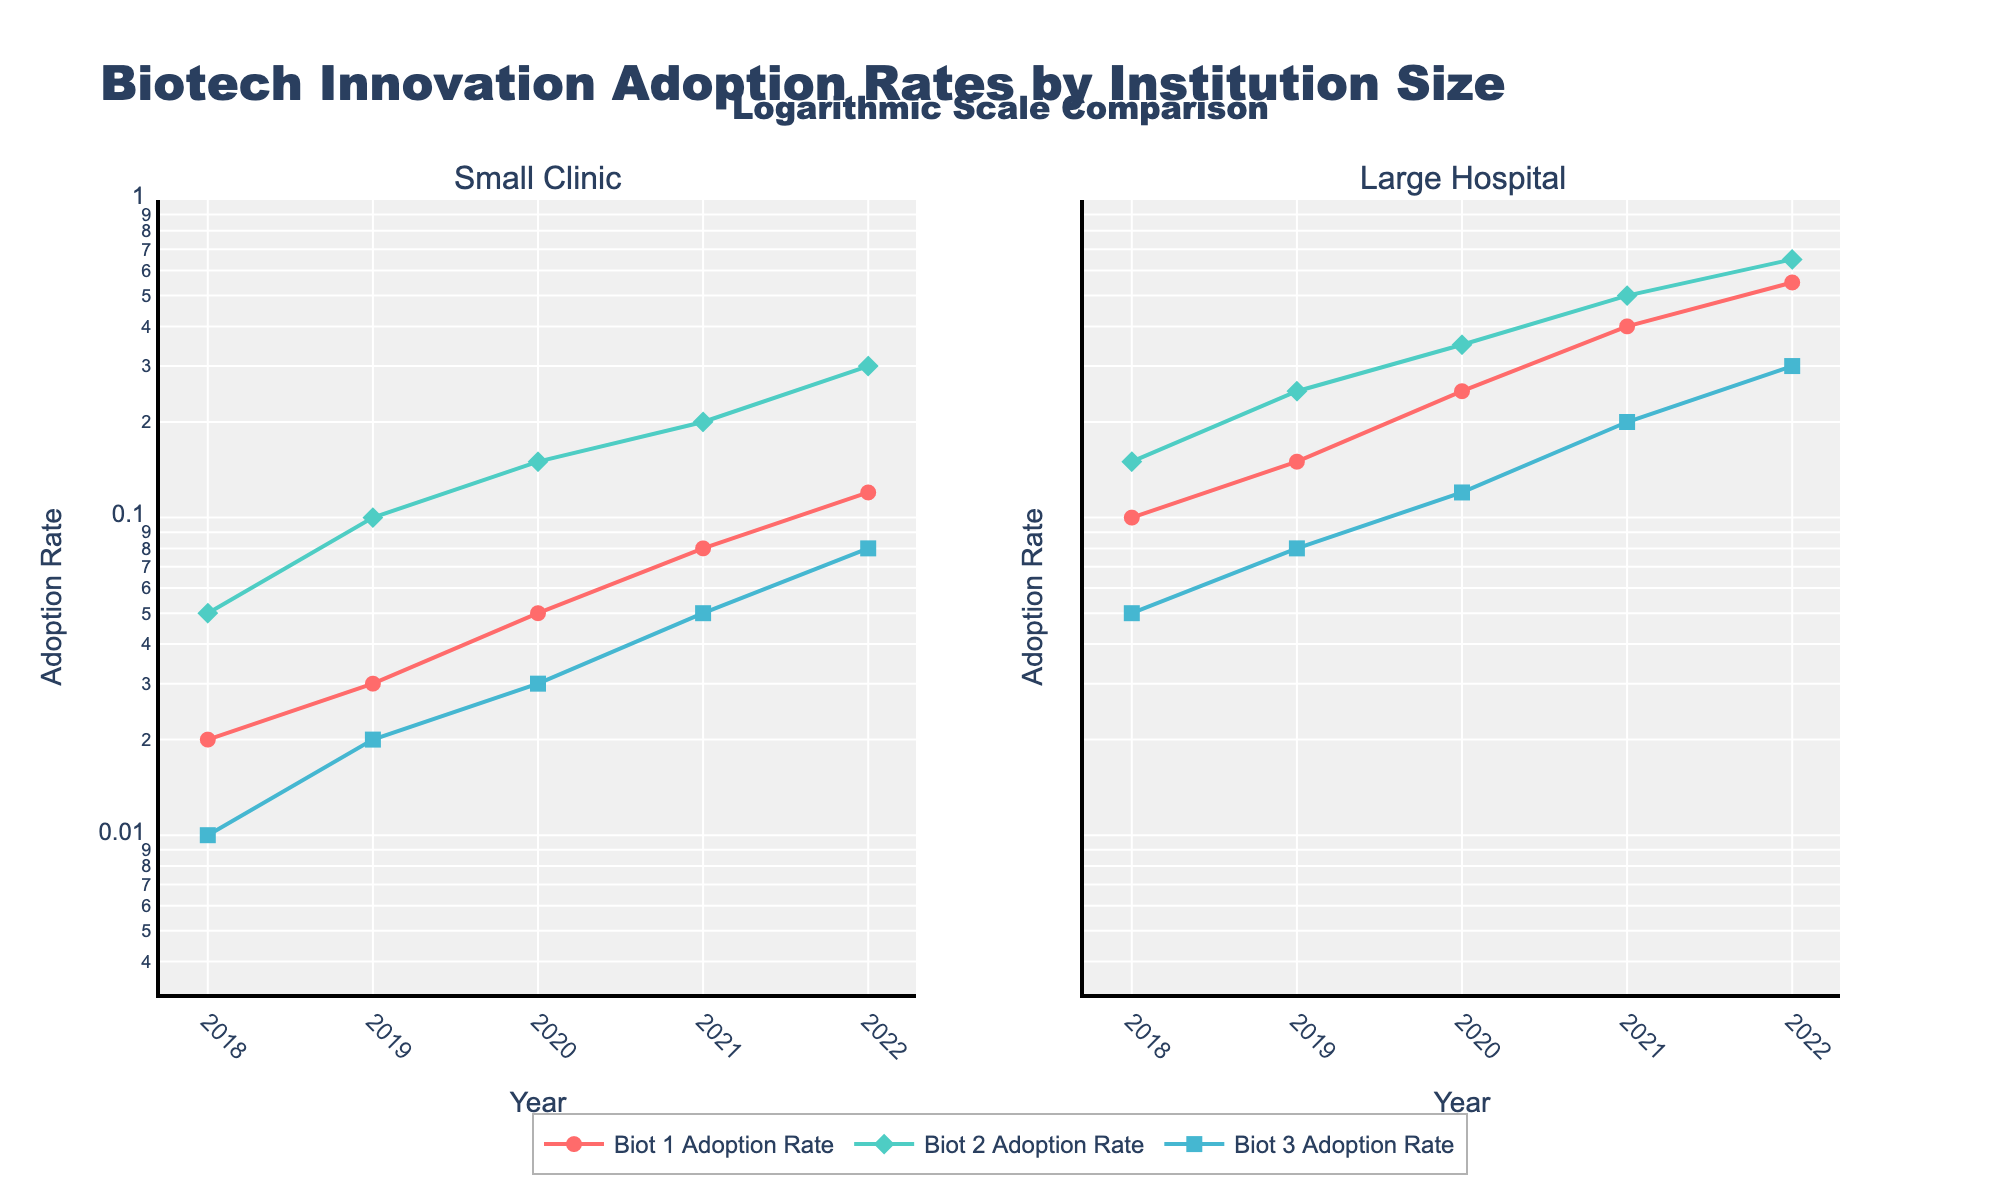What is the title of the figure? The title of the figure is clearly displayed at the top and reads "Biotech Innovation Adoption Rates by Institution Size".
Answer: Biotech Innovation Adoption Rates by Institution Size Which institution size has higher adoption rates overall in 2022 for all biotechs? By comparing the adoption rates for Biot 1, Biot 2, and Biot 3 in 2022, the large hospital data points (0.55, 0.65, 0.30) are higher than the small clinic data points (0.12, 0.30, 0.08) across all biotechs.
Answer: Large Hospital How does the adoption rate of Biot 1 in 2020 differ between small clinics and large hospitals? In 2020, Biot 1's adoption rate is 0.05 for small clinics and 0.25 for large hospitals. The difference is calculated as 0.25 - 0.05.
Answer: 0.20 What has been the trend in adoption rates for Biot 2 in large hospitals from 2018 to 2022? Observing the large hospital subplot for Biot 2 from 2018 to 2022, the trend shows a consistent increase each year from 0.15 to 0.65.
Answer: Increasing What can you infer from the logarithmic scale about the growth rates in adoption for small clinics versus large hospitals? In a logarithmic scale, the linearity and slope represent multiplicative factors of growth. The steeper slope for large hospitals indicates faster exponential growth compared to the smaller, steadier slope for small clinics.
Answer: Large hospitals have faster exponential growth What is the average adoption rate of Biot 3 in small clinics between 2018 and 2022? The adoption rates in small clinics for Biot 3 from 2018 to 2022 are 0.01, 0.02, 0.03, 0.05, and 0.08. The average can be found by summing these values and dividing by 5: (0.01 + 0.02 + 0.03 + 0.05 + 0.08) / 5.
Answer: 0.038 Are there any biotechs where the adoption rate in small clinics is equal to or exceeds that in large hospitals in any year? Examine the adoption rates year by year. None of the small clinic rates surpass or match the large hospital rates for any biotech in any year.
Answer: No In which year does the adoption rate of Biot 3 in large hospitals first reach double digits (0.1 or above)? Checking the large hospital data for Biot 3, in 2020 the rate is 0.12 which is the first year it exceeds 0.1.
Answer: 2020 Between Biot 1 and Biot 2, which had a greater increase in adoption rates from 2018 to 2022 in small clinics? For small clinics, Biot 1's adoption rate increased from 0.02 to 0.12 (0.10 increase), and Biot 2's rate increased from 0.05 to 0.30 (0.25 increase). Hence, Biot 2 had a greater increase.
Answer: Biot 2 What kind of scale is used on the y-axis, and why is it useful here? The y-axis uses a logarithmic scale, which is useful to show exponential growth patterns and compare growth rates across different orders of magnitude.
Answer: Logarithmic scale 